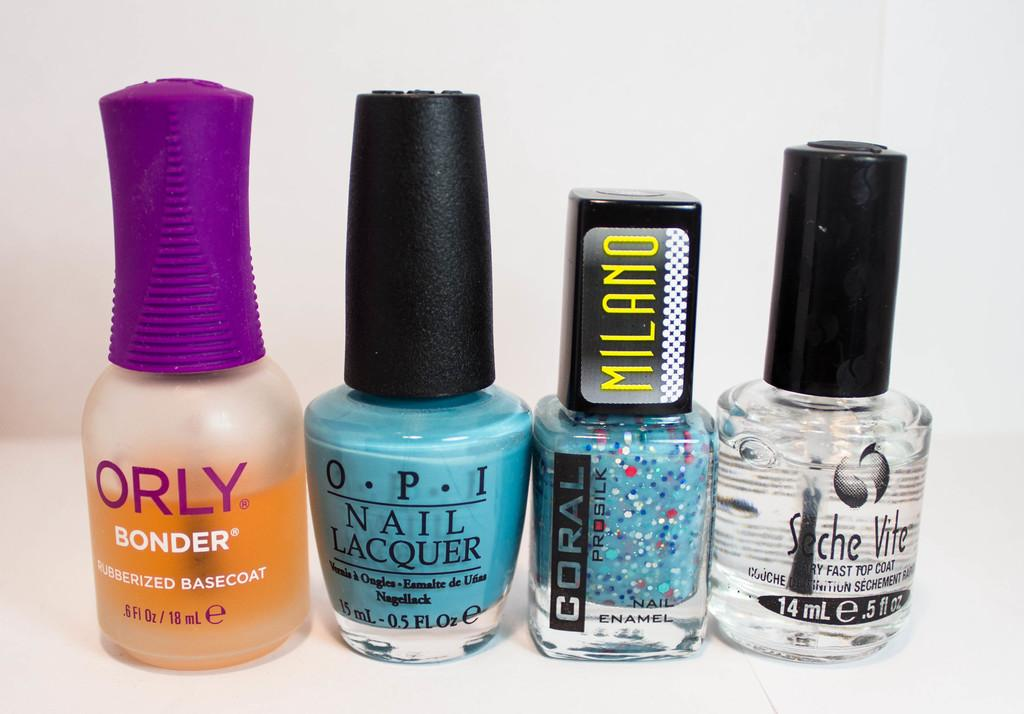What is the main color of the surface in the image? The main color of the surface in the image is white. What objects are placed on the white surface? There are four nail polishes on the white surface. What can be seen in the background of the image? The background of the image is white. What is the name of the daughter who is playing with the van in the image? There is no daughter or van present in the image. What type of print can be seen on the surface of the van in the image? There is no van present in the image, so there is no print to describe. 